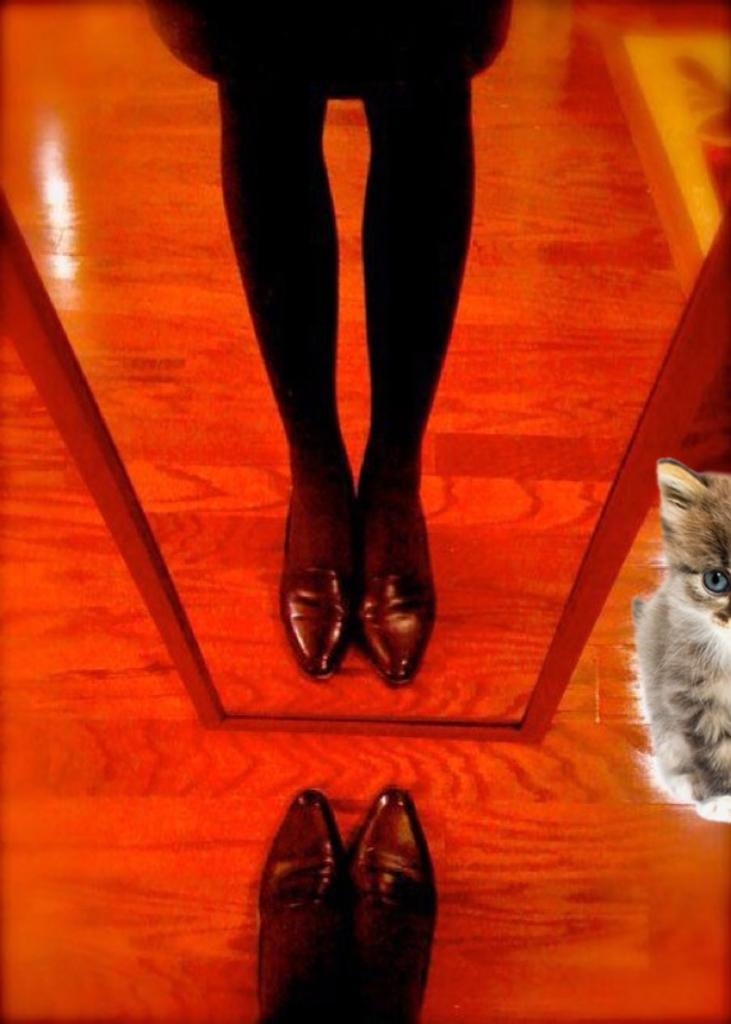What part of a person can be seen in the image? There is a person's leg in the image. What type of surface is visible in the image? There is ground visible in the image. What animal is present in the image? There is a cat in the image. What object allows for reflection in the image? There is a mirror in the image. Whose reflection can be seen in the mirror? The reflection of the person is visible in the mirror. How many ants are crawling on the person's leg in the image? There are no ants visible in the image; only a person's leg, ground, a cat, a mirror, and the person's reflection can be seen. What type of ball is being used by the person in the image? There is no ball present in the image. 